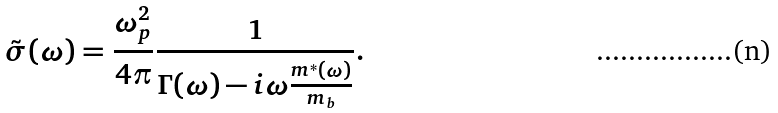<formula> <loc_0><loc_0><loc_500><loc_500>\tilde { \sigma } ( \omega ) = \frac { \omega ^ { 2 } _ { p } } { 4 \pi } \frac { 1 } { \Gamma ( \omega ) - i \omega \frac { m ^ { * } ( \omega ) } { m _ { b } } } .</formula> 